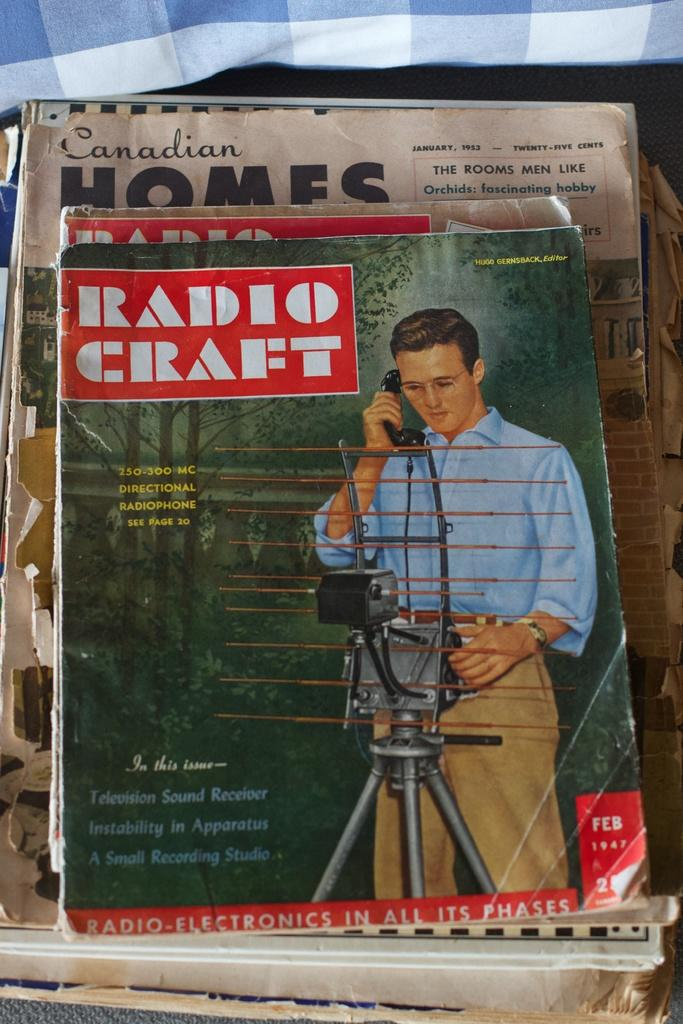<image>
Give a short and clear explanation of the subsequent image. A man on the front of a Radio Craft magazine. 